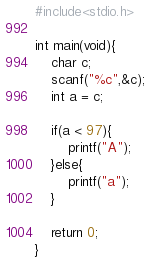<code> <loc_0><loc_0><loc_500><loc_500><_C_>#include<stdio.h>

int main(void){
    char c;
    scanf("%c",&c);
    int a = c;

    if(a < 97){
        printf("A");
    }else{
        printf("a");
    }

    return 0;
}</code> 